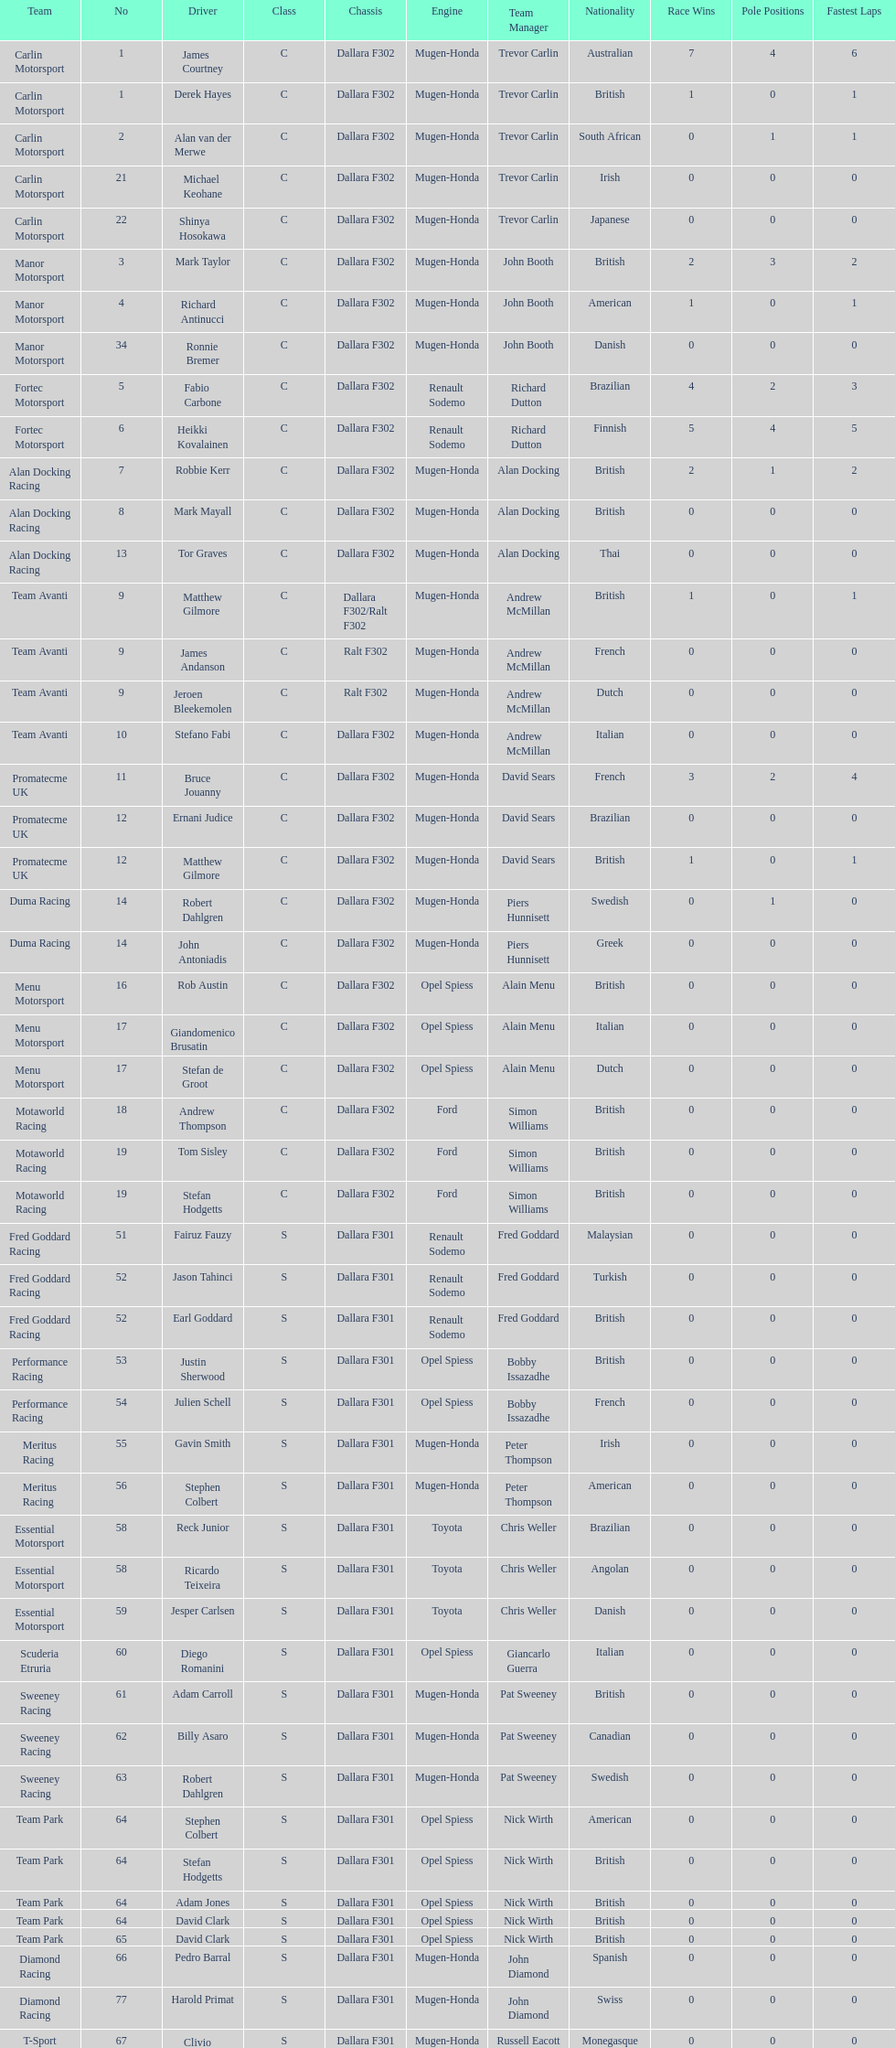What team is listed above diamond racing? Team Park. 